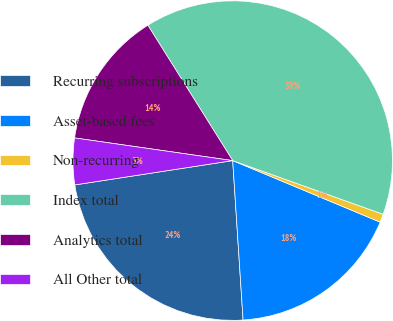Convert chart. <chart><loc_0><loc_0><loc_500><loc_500><pie_chart><fcel>Recurring subscriptions<fcel>Asset-based fees<fcel>Non-recurring<fcel>Index total<fcel>Analytics total<fcel>All Other total<nl><fcel>23.6%<fcel>17.67%<fcel>0.84%<fcel>39.36%<fcel>13.82%<fcel>4.7%<nl></chart> 